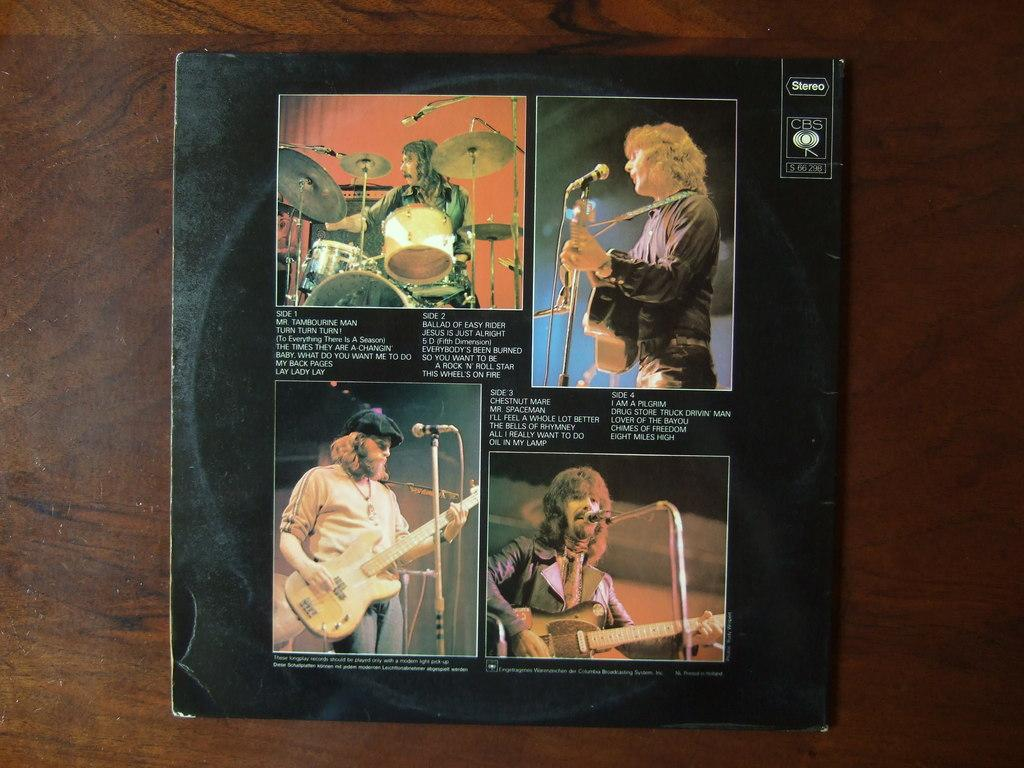<image>
Summarize the visual content of the image. Mr. Tambourine Man is the first song shown on this CD cover. 